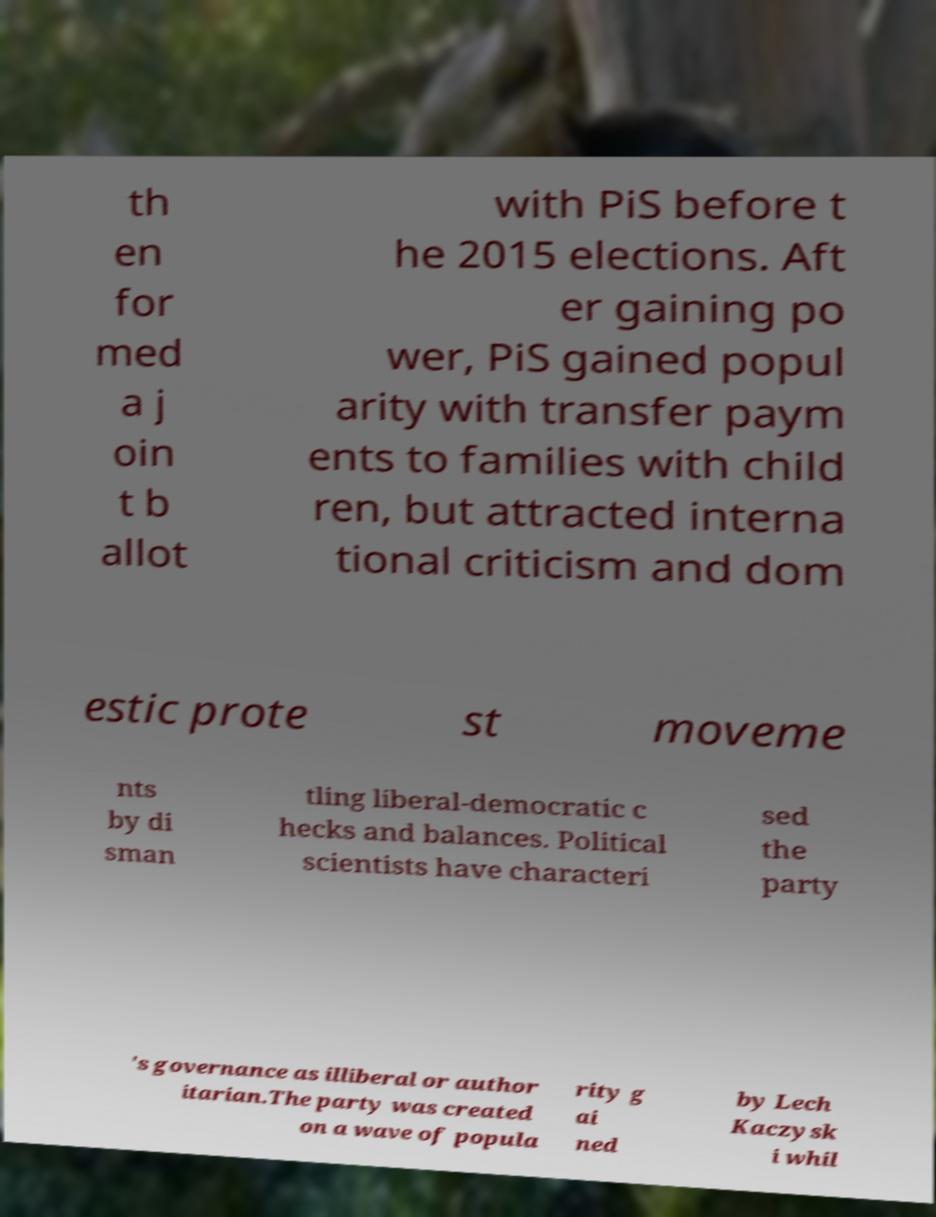There's text embedded in this image that I need extracted. Can you transcribe it verbatim? th en for med a j oin t b allot with PiS before t he 2015 elections. Aft er gaining po wer, PiS gained popul arity with transfer paym ents to families with child ren, but attracted interna tional criticism and dom estic prote st moveme nts by di sman tling liberal-democratic c hecks and balances. Political scientists have characteri sed the party 's governance as illiberal or author itarian.The party was created on a wave of popula rity g ai ned by Lech Kaczysk i whil 